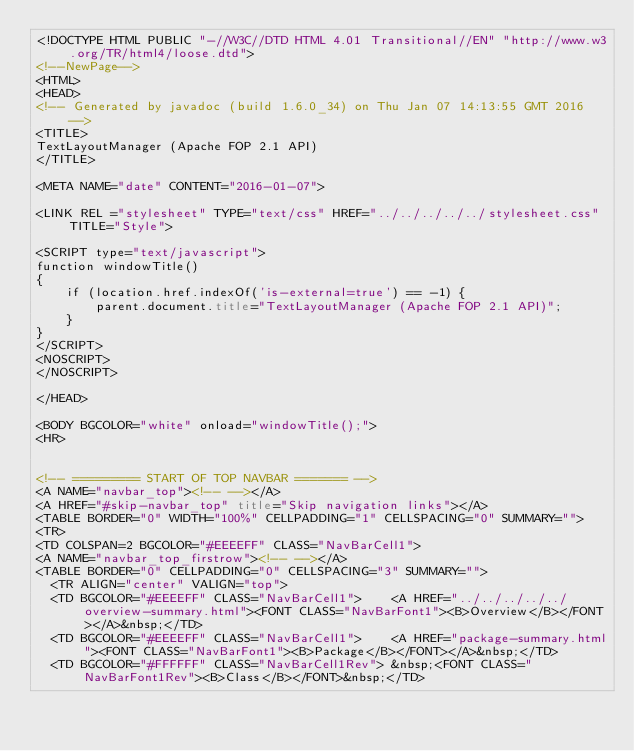<code> <loc_0><loc_0><loc_500><loc_500><_HTML_><!DOCTYPE HTML PUBLIC "-//W3C//DTD HTML 4.01 Transitional//EN" "http://www.w3.org/TR/html4/loose.dtd">
<!--NewPage-->
<HTML>
<HEAD>
<!-- Generated by javadoc (build 1.6.0_34) on Thu Jan 07 14:13:55 GMT 2016 -->
<TITLE>
TextLayoutManager (Apache FOP 2.1 API)
</TITLE>

<META NAME="date" CONTENT="2016-01-07">

<LINK REL ="stylesheet" TYPE="text/css" HREF="../../../../../stylesheet.css" TITLE="Style">

<SCRIPT type="text/javascript">
function windowTitle()
{
    if (location.href.indexOf('is-external=true') == -1) {
        parent.document.title="TextLayoutManager (Apache FOP 2.1 API)";
    }
}
</SCRIPT>
<NOSCRIPT>
</NOSCRIPT>

</HEAD>

<BODY BGCOLOR="white" onload="windowTitle();">
<HR>


<!-- ========= START OF TOP NAVBAR ======= -->
<A NAME="navbar_top"><!-- --></A>
<A HREF="#skip-navbar_top" title="Skip navigation links"></A>
<TABLE BORDER="0" WIDTH="100%" CELLPADDING="1" CELLSPACING="0" SUMMARY="">
<TR>
<TD COLSPAN=2 BGCOLOR="#EEEEFF" CLASS="NavBarCell1">
<A NAME="navbar_top_firstrow"><!-- --></A>
<TABLE BORDER="0" CELLPADDING="0" CELLSPACING="3" SUMMARY="">
  <TR ALIGN="center" VALIGN="top">
  <TD BGCOLOR="#EEEEFF" CLASS="NavBarCell1">    <A HREF="../../../../../overview-summary.html"><FONT CLASS="NavBarFont1"><B>Overview</B></FONT></A>&nbsp;</TD>
  <TD BGCOLOR="#EEEEFF" CLASS="NavBarCell1">    <A HREF="package-summary.html"><FONT CLASS="NavBarFont1"><B>Package</B></FONT></A>&nbsp;</TD>
  <TD BGCOLOR="#FFFFFF" CLASS="NavBarCell1Rev"> &nbsp;<FONT CLASS="NavBarFont1Rev"><B>Class</B></FONT>&nbsp;</TD></code> 